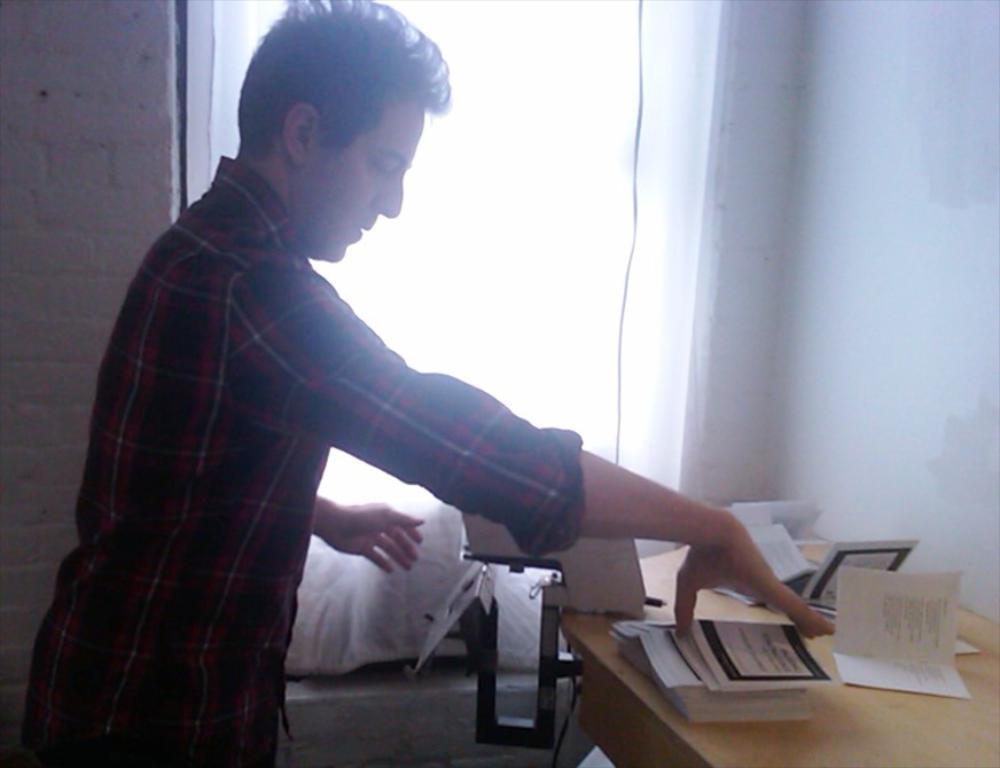Please provide a concise description of this image. In this image we can see a man is standing and holding the books in the hand, and in front here is the table and books on it, and here is the wall and here is the window. 